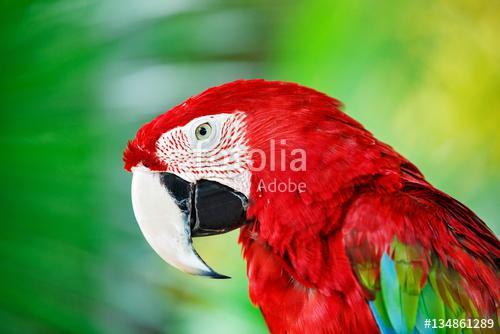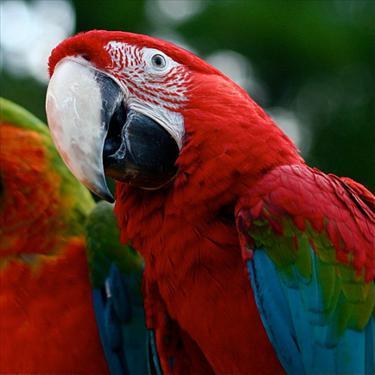The first image is the image on the left, the second image is the image on the right. Assess this claim about the two images: "No image contains more than two parrot-type birds, and each image contains exactly one red-headed bird.". Correct or not? Answer yes or no. Yes. The first image is the image on the left, the second image is the image on the right. Examine the images to the left and right. Is the description "There is one predominately red bird perched in the image on the left." accurate? Answer yes or no. Yes. 